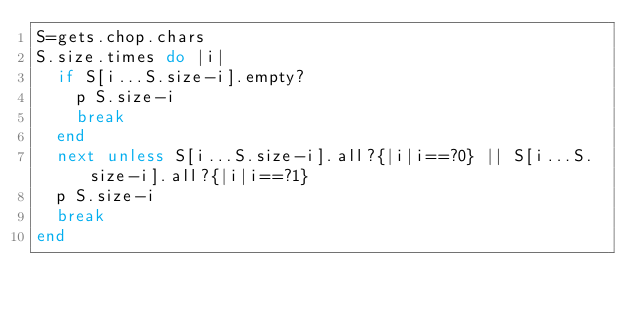Convert code to text. <code><loc_0><loc_0><loc_500><loc_500><_Ruby_>S=gets.chop.chars
S.size.times do |i|
  if S[i...S.size-i].empty?
    p S.size-i
    break
  end
  next unless S[i...S.size-i].all?{|i|i==?0} || S[i...S.size-i].all?{|i|i==?1}
  p S.size-i
  break
end
</code> 